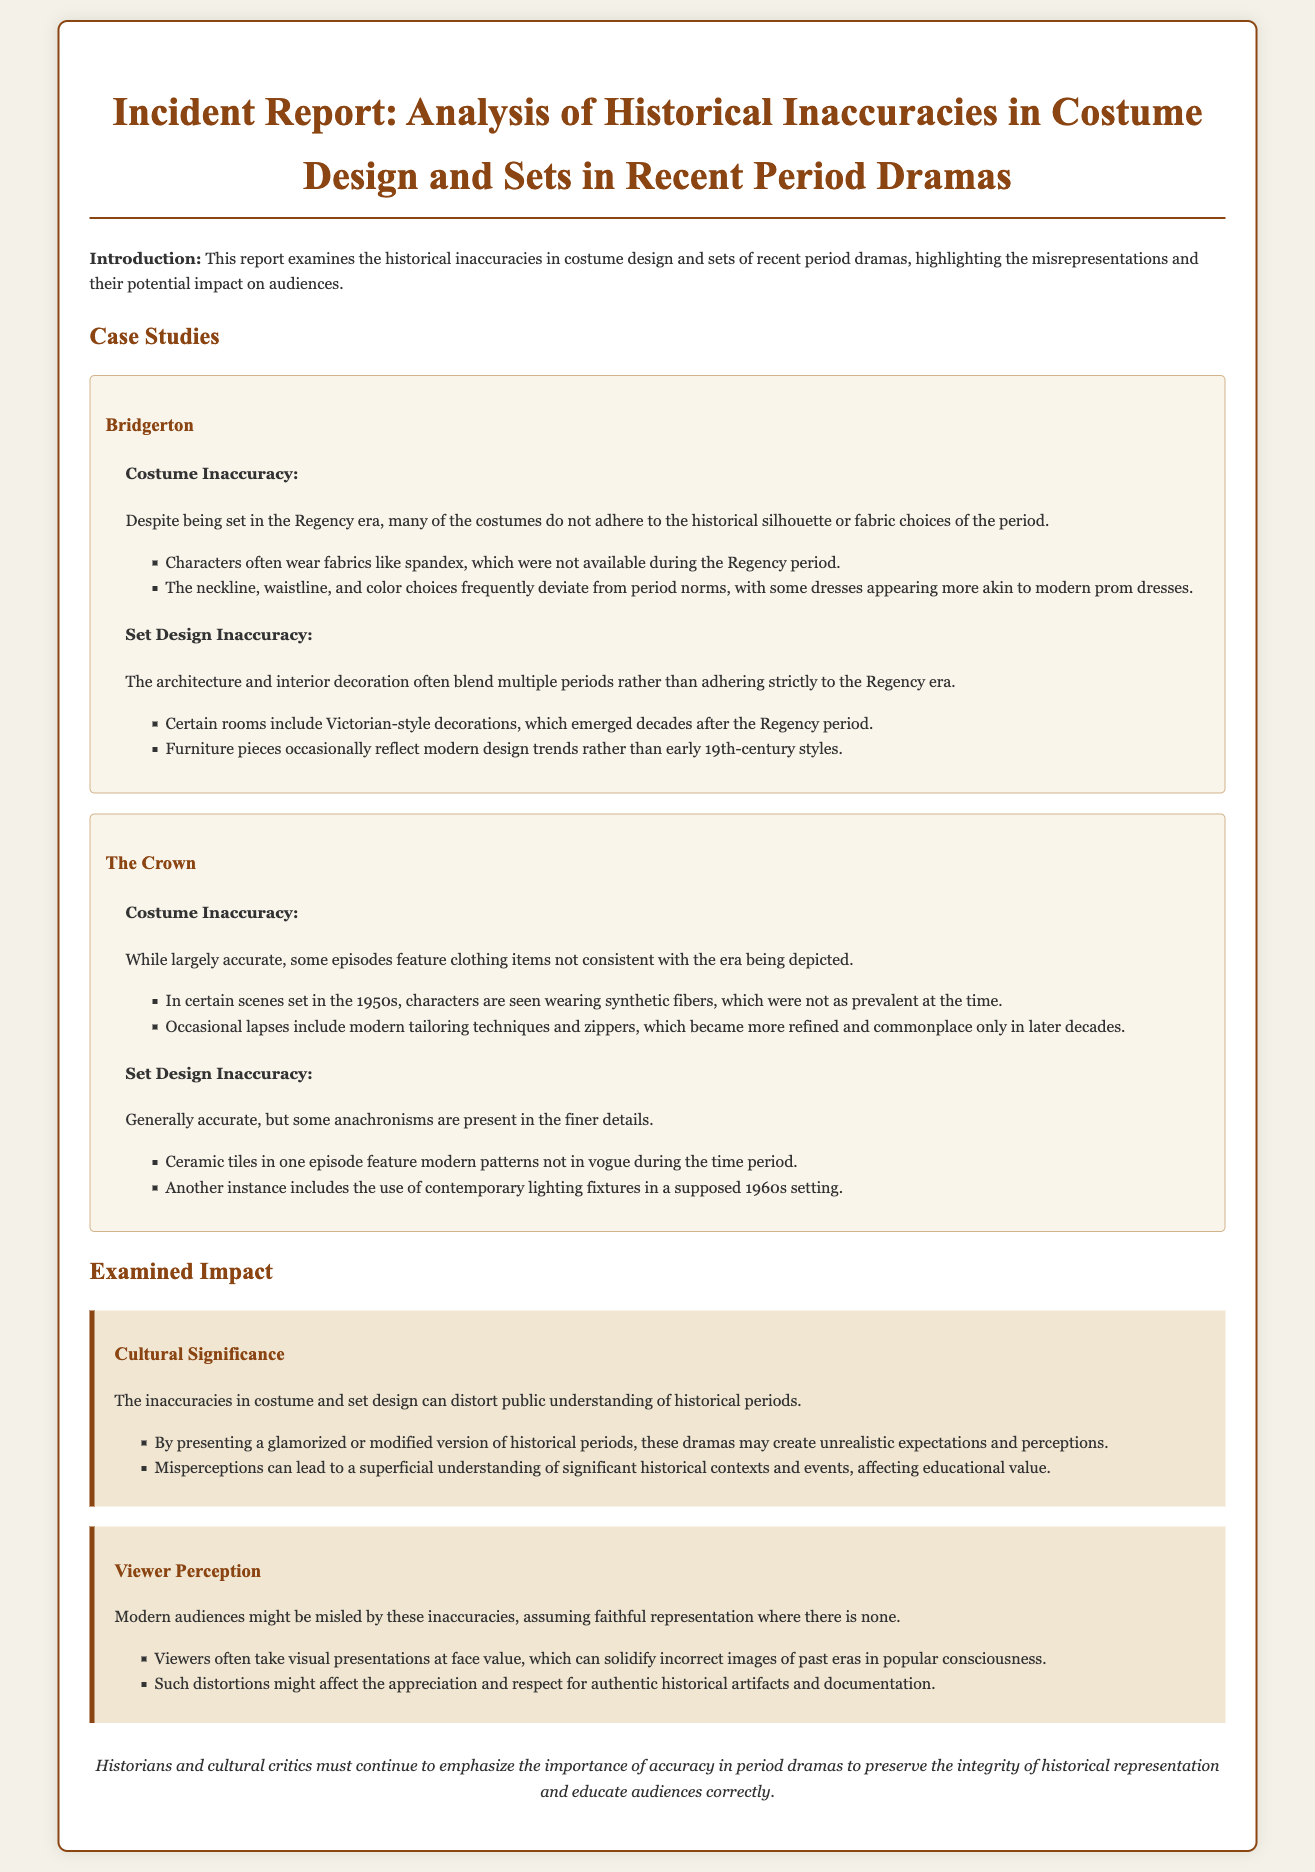What is the title of the report? The title of the report is prominently displayed at the top of the document.
Answer: Incident Report: Analysis of Historical Inaccuracies in Costume Design and Sets in Recent Period Dramas Which period does "Bridgerton" claim to represent? The report specifies the time period in which "Bridgerton" is set, as mentioned in the discussions on inaccuracies.
Answer: Regency era What type of fabric is inaccurately used in "Bridgerton"? The report explicitly lists a fabric that was not available during the Regency period in the description of inaccuracies.
Answer: Spandex In "The Crown," what decade does the report mention as having inaccuracies? The report points out specific timeframes where inaccuracies in the costume design occur.
Answer: 1950s What is one impact discussed regarding cultural significance? The report outlines the effects of inaccuracies on public understanding within a specific section.
Answer: Distort public understanding What is one consequence of viewer perception as mentioned in the report? This reasoning relates to how viewers interpret the visuals presented in period dramas, affecting cultural appreciation.
Answer: Solidify incorrect images How many main productions are analyzed in the document? The document breaks down the inaccuracies in two productions, as stated in the case studies section.
Answer: Two What is emphasized in the conclusion of the report? The conclusion states a key point that is important for historical representation and education.
Answer: Importance of accuracy Which architectural style is inaccurately included in "Bridgerton"? The report specifically mentions the style that does not belong to the Regency period in its set design inaccuracies.
Answer: Victorian-style 